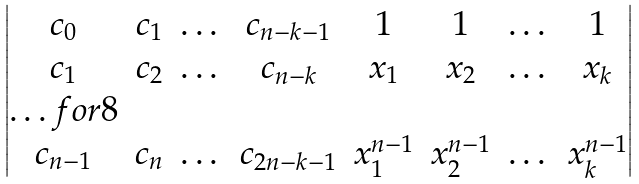Convert formula to latex. <formula><loc_0><loc_0><loc_500><loc_500>\begin{vmatrix} c _ { 0 } & c _ { 1 } & \dots & c _ { n - k - 1 } & 1 & 1 & \dots & 1 \\ c _ { 1 } & c _ { 2 } & \dots & c _ { n - k } & x _ { 1 } & x _ { 2 } & \dots & x _ { k } \\ \hdots f o r { 8 } \\ c _ { n - 1 } & c _ { n } & \dots & c _ { 2 n - k - 1 } & x _ { 1 } ^ { n - 1 } & x _ { 2 } ^ { n - 1 } & \dots & x _ { k } ^ { n - 1 } \end{vmatrix}</formula> 